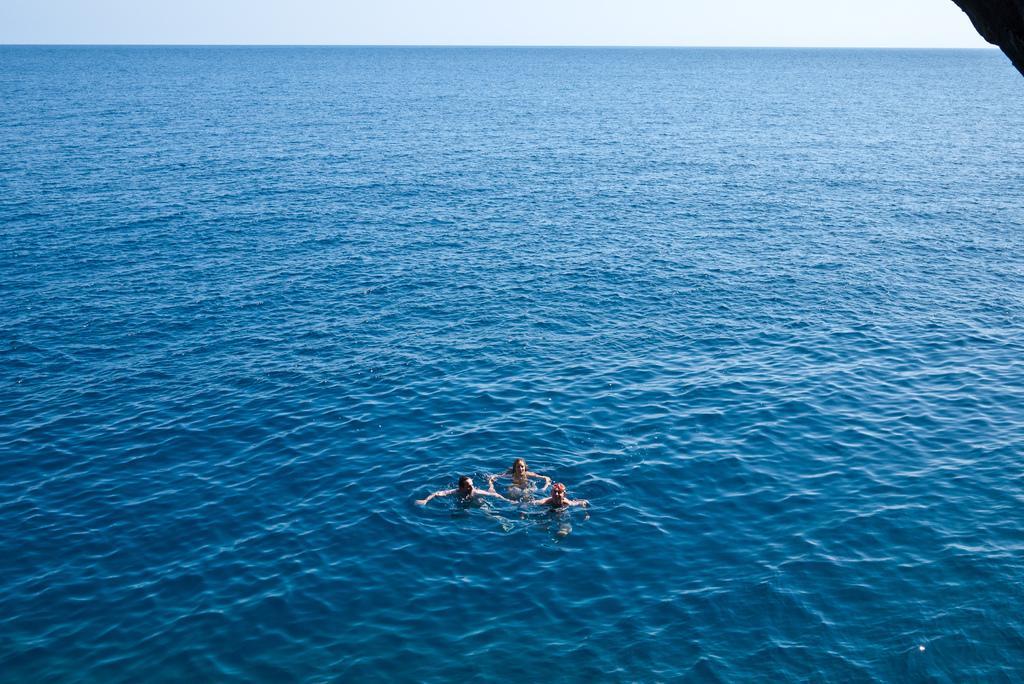In one or two sentences, can you explain what this image depicts? In this picture, we see three people are swimming in the water. In the background, we see the water and this water might be in the sea. At the top, we see the sky. In the right top, it is black in color and it might be the rock. 